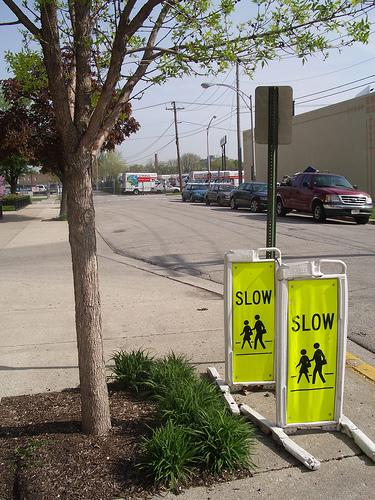Question: what color are the signs?
Choices:
A. Yellow.
B. Orange.
C. Red.
D. Green.
Answer with the letter. Answer: A Question: who is in this photo?
Choices:
A. A dog.
B. A cat.
C. No people in this photo.
D. A bird.
Answer with the letter. Answer: C Question: why are the signs there?
Choices:
A. To make sure people stop at intersection.
B. To make sure people drive the speed limit.
C. To make sure people drive slow due to pedestrians.
D. To make sure people drive carefully on the curve.
Answer with the letter. Answer: C Question: how are the yellow signs positioned?
Choices:
A. Next to each other.
B. One in front of the other.
C. One on top of the other.
D. 2 feet apart.
Answer with the letter. Answer: B Question: what do the yellow signs have written on them?
Choices:
A. Yield.
B. Hazard.
C. SLOW.
D. Construction.
Answer with the letter. Answer: C 